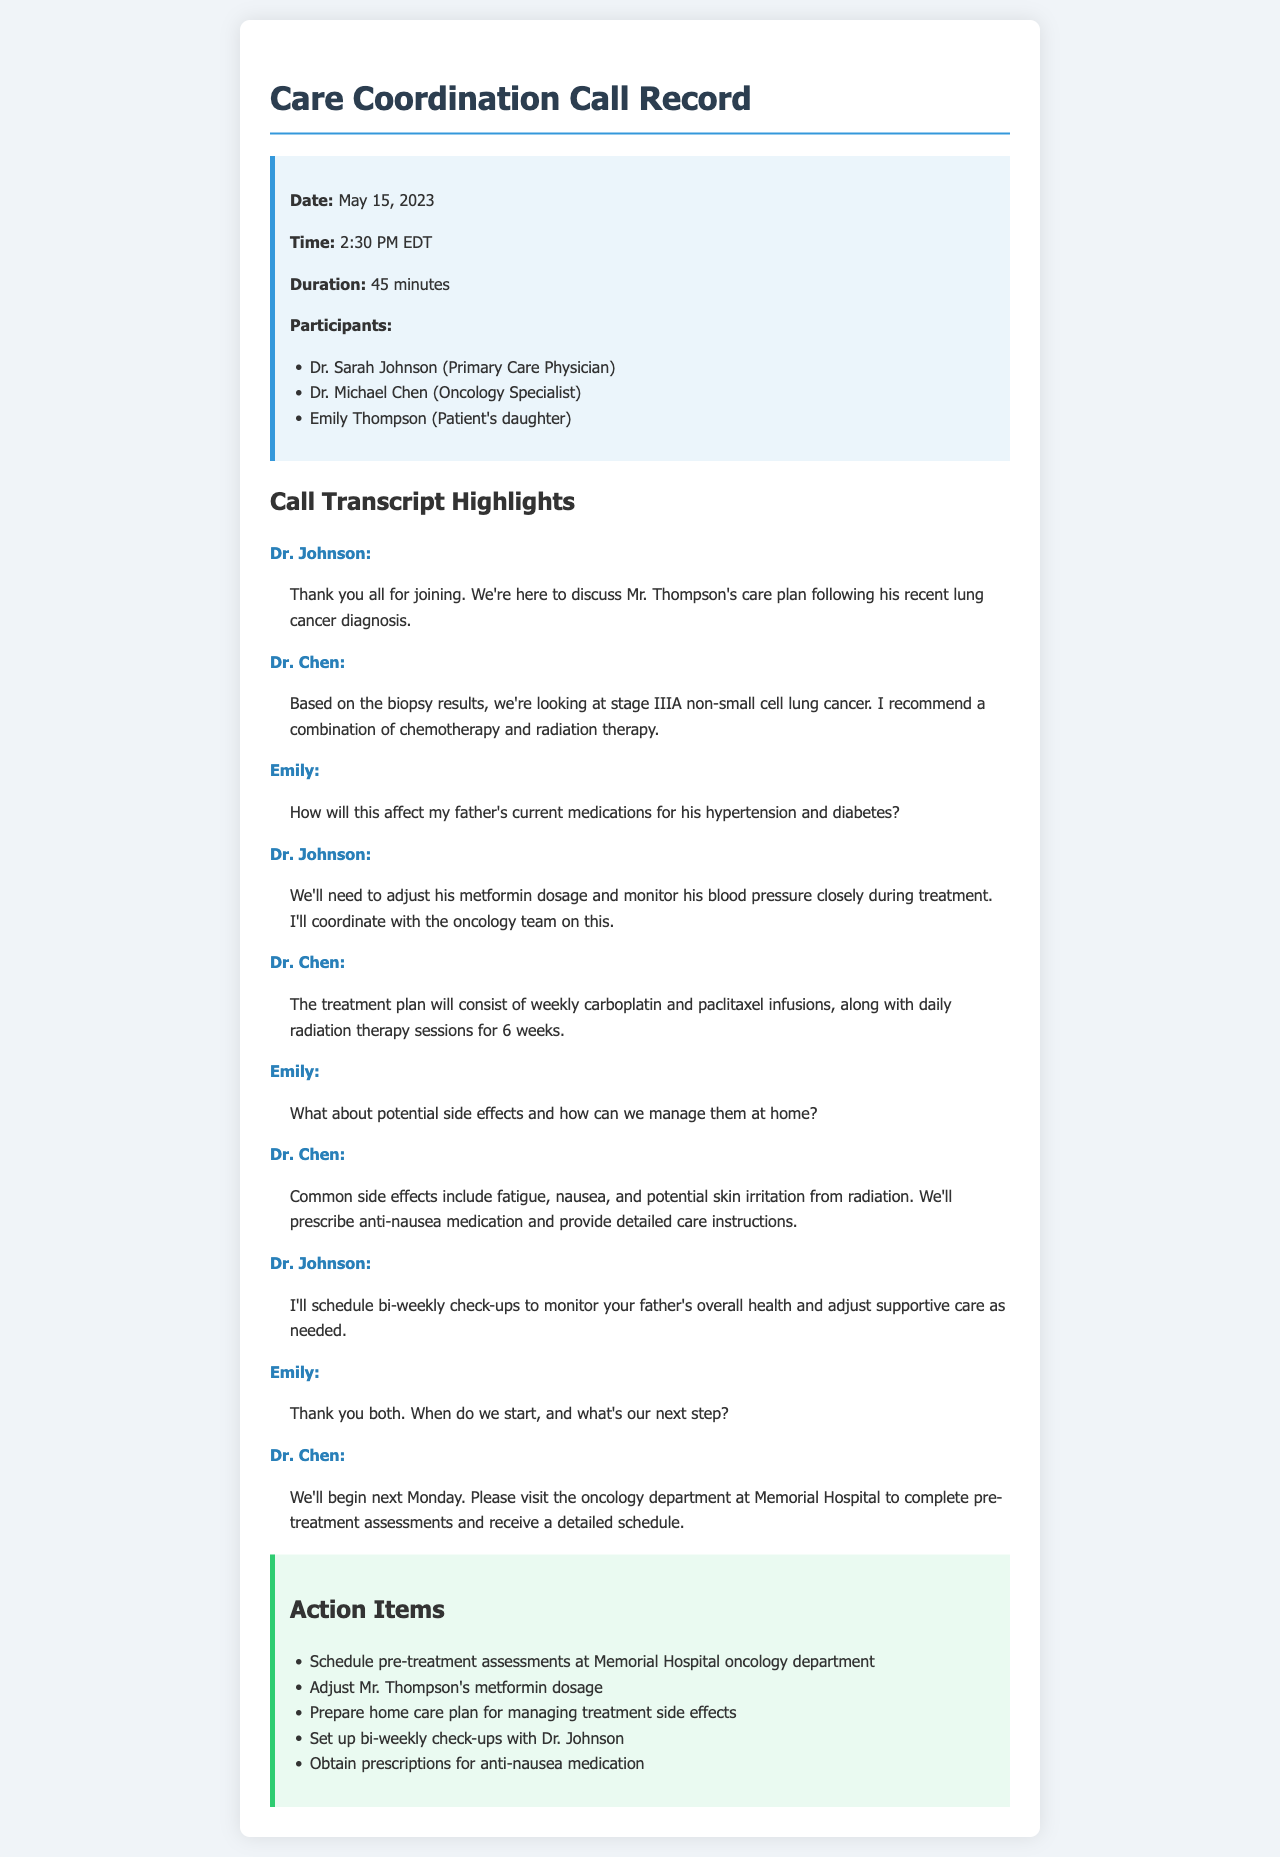What is the date of the call? The date of the call is listed in the call details section of the document.
Answer: May 15, 2023 Who is the primary care physician? The document provides a list of participants, including their roles.
Answer: Dr. Sarah Johnson What stage of lung cancer was diagnosed? The diagnosis stage is mentioned in Dr. Chen's statement during the call.
Answer: stage IIIA What medication will need adjusting? Dr. Johnson discusses a necessary adjustment during the call.
Answer: metformin What is the duration of the call? The duration of the call is specified in the call details section.
Answer: 45 minutes What side effect is common from the radiation therapy? Dr. Chen mentions common side effects during the call.
Answer: fatigue How often will the check-ups be scheduled? Dr. Johnson states the frequency of check-ups during the call.
Answer: bi-weekly When do they plan to start treatment? Dr. Chen provides the start date of the treatment during the call.
Answer: next Monday What is the first action item? The document lists action items that need to be completed.
Answer: Schedule pre-treatment assessments at Memorial Hospital oncology department 